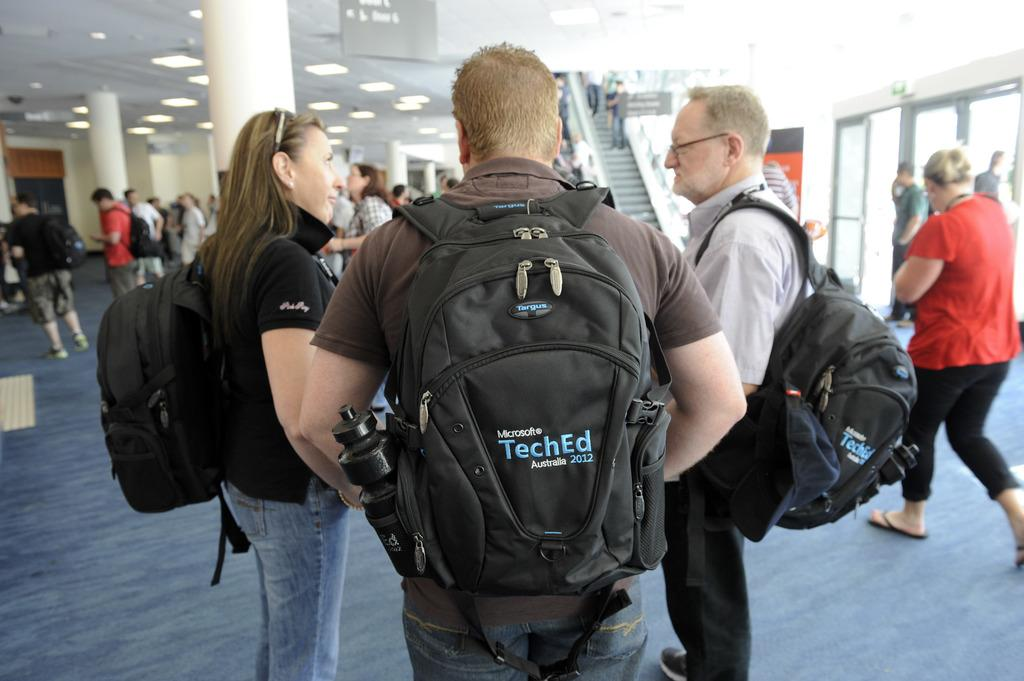<image>
Give a short and clear explanation of the subsequent image. Man wearing a TechEd backpack talking with others. 